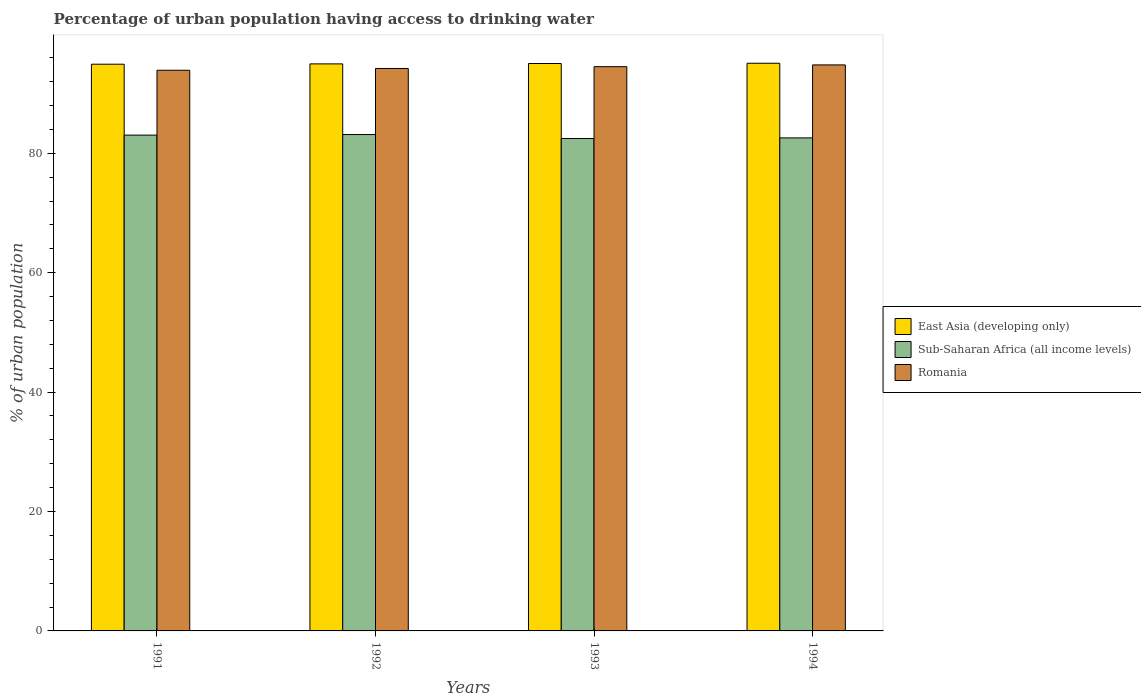How many different coloured bars are there?
Make the answer very short. 3. What is the label of the 1st group of bars from the left?
Provide a succinct answer. 1991. In how many cases, is the number of bars for a given year not equal to the number of legend labels?
Your answer should be compact. 0. What is the percentage of urban population having access to drinking water in Sub-Saharan Africa (all income levels) in 1991?
Your response must be concise. 83.04. Across all years, what is the maximum percentage of urban population having access to drinking water in Romania?
Offer a terse response. 94.8. Across all years, what is the minimum percentage of urban population having access to drinking water in Sub-Saharan Africa (all income levels)?
Offer a very short reply. 82.47. In which year was the percentage of urban population having access to drinking water in East Asia (developing only) maximum?
Ensure brevity in your answer.  1994. In which year was the percentage of urban population having access to drinking water in East Asia (developing only) minimum?
Your response must be concise. 1991. What is the total percentage of urban population having access to drinking water in Romania in the graph?
Your answer should be compact. 377.4. What is the difference between the percentage of urban population having access to drinking water in East Asia (developing only) in 1993 and that in 1994?
Give a very brief answer. -0.04. What is the difference between the percentage of urban population having access to drinking water in Romania in 1992 and the percentage of urban population having access to drinking water in Sub-Saharan Africa (all income levels) in 1994?
Ensure brevity in your answer.  11.63. What is the average percentage of urban population having access to drinking water in East Asia (developing only) per year?
Ensure brevity in your answer.  95. In the year 1991, what is the difference between the percentage of urban population having access to drinking water in Sub-Saharan Africa (all income levels) and percentage of urban population having access to drinking water in Romania?
Your answer should be compact. -10.86. What is the ratio of the percentage of urban population having access to drinking water in Sub-Saharan Africa (all income levels) in 1992 to that in 1993?
Your answer should be very brief. 1.01. What is the difference between the highest and the second highest percentage of urban population having access to drinking water in Sub-Saharan Africa (all income levels)?
Your response must be concise. 0.1. What is the difference between the highest and the lowest percentage of urban population having access to drinking water in Sub-Saharan Africa (all income levels)?
Your response must be concise. 0.66. What does the 2nd bar from the left in 1994 represents?
Make the answer very short. Sub-Saharan Africa (all income levels). What does the 3rd bar from the right in 1992 represents?
Your answer should be compact. East Asia (developing only). Is it the case that in every year, the sum of the percentage of urban population having access to drinking water in Romania and percentage of urban population having access to drinking water in Sub-Saharan Africa (all income levels) is greater than the percentage of urban population having access to drinking water in East Asia (developing only)?
Offer a very short reply. Yes. How many bars are there?
Your response must be concise. 12. Are all the bars in the graph horizontal?
Provide a short and direct response. No. What is the difference between two consecutive major ticks on the Y-axis?
Offer a terse response. 20. Does the graph contain grids?
Keep it short and to the point. No. Where does the legend appear in the graph?
Provide a short and direct response. Center right. How many legend labels are there?
Your answer should be very brief. 3. What is the title of the graph?
Make the answer very short. Percentage of urban population having access to drinking water. Does "Bulgaria" appear as one of the legend labels in the graph?
Offer a very short reply. No. What is the label or title of the X-axis?
Give a very brief answer. Years. What is the label or title of the Y-axis?
Provide a short and direct response. % of urban population. What is the % of urban population in East Asia (developing only) in 1991?
Offer a very short reply. 94.91. What is the % of urban population in Sub-Saharan Africa (all income levels) in 1991?
Offer a very short reply. 83.04. What is the % of urban population of Romania in 1991?
Your answer should be very brief. 93.9. What is the % of urban population of East Asia (developing only) in 1992?
Provide a short and direct response. 94.97. What is the % of urban population of Sub-Saharan Africa (all income levels) in 1992?
Ensure brevity in your answer.  83.13. What is the % of urban population in Romania in 1992?
Make the answer very short. 94.2. What is the % of urban population in East Asia (developing only) in 1993?
Your response must be concise. 95.03. What is the % of urban population of Sub-Saharan Africa (all income levels) in 1993?
Offer a very short reply. 82.47. What is the % of urban population in Romania in 1993?
Your answer should be very brief. 94.5. What is the % of urban population of East Asia (developing only) in 1994?
Offer a terse response. 95.07. What is the % of urban population of Sub-Saharan Africa (all income levels) in 1994?
Provide a short and direct response. 82.57. What is the % of urban population in Romania in 1994?
Offer a very short reply. 94.8. Across all years, what is the maximum % of urban population in East Asia (developing only)?
Offer a terse response. 95.07. Across all years, what is the maximum % of urban population of Sub-Saharan Africa (all income levels)?
Offer a very short reply. 83.13. Across all years, what is the maximum % of urban population of Romania?
Offer a very short reply. 94.8. Across all years, what is the minimum % of urban population of East Asia (developing only)?
Offer a terse response. 94.91. Across all years, what is the minimum % of urban population in Sub-Saharan Africa (all income levels)?
Make the answer very short. 82.47. Across all years, what is the minimum % of urban population in Romania?
Provide a succinct answer. 93.9. What is the total % of urban population of East Asia (developing only) in the graph?
Offer a terse response. 379.99. What is the total % of urban population in Sub-Saharan Africa (all income levels) in the graph?
Make the answer very short. 331.22. What is the total % of urban population in Romania in the graph?
Ensure brevity in your answer.  377.4. What is the difference between the % of urban population of East Asia (developing only) in 1991 and that in 1992?
Offer a terse response. -0.05. What is the difference between the % of urban population of Sub-Saharan Africa (all income levels) in 1991 and that in 1992?
Ensure brevity in your answer.  -0.1. What is the difference between the % of urban population of Romania in 1991 and that in 1992?
Keep it short and to the point. -0.3. What is the difference between the % of urban population in East Asia (developing only) in 1991 and that in 1993?
Your response must be concise. -0.12. What is the difference between the % of urban population in Sub-Saharan Africa (all income levels) in 1991 and that in 1993?
Offer a terse response. 0.57. What is the difference between the % of urban population of Romania in 1991 and that in 1993?
Your answer should be compact. -0.6. What is the difference between the % of urban population of East Asia (developing only) in 1991 and that in 1994?
Offer a terse response. -0.16. What is the difference between the % of urban population of Sub-Saharan Africa (all income levels) in 1991 and that in 1994?
Your answer should be very brief. 0.47. What is the difference between the % of urban population in Romania in 1991 and that in 1994?
Ensure brevity in your answer.  -0.9. What is the difference between the % of urban population in East Asia (developing only) in 1992 and that in 1993?
Give a very brief answer. -0.06. What is the difference between the % of urban population in Sub-Saharan Africa (all income levels) in 1992 and that in 1993?
Your answer should be compact. 0.66. What is the difference between the % of urban population in Romania in 1992 and that in 1993?
Ensure brevity in your answer.  -0.3. What is the difference between the % of urban population in East Asia (developing only) in 1992 and that in 1994?
Offer a terse response. -0.11. What is the difference between the % of urban population in Sub-Saharan Africa (all income levels) in 1992 and that in 1994?
Keep it short and to the point. 0.56. What is the difference between the % of urban population in East Asia (developing only) in 1993 and that in 1994?
Offer a terse response. -0.04. What is the difference between the % of urban population of Sub-Saharan Africa (all income levels) in 1993 and that in 1994?
Offer a very short reply. -0.1. What is the difference between the % of urban population of Romania in 1993 and that in 1994?
Provide a short and direct response. -0.3. What is the difference between the % of urban population in East Asia (developing only) in 1991 and the % of urban population in Sub-Saharan Africa (all income levels) in 1992?
Offer a very short reply. 11.78. What is the difference between the % of urban population of East Asia (developing only) in 1991 and the % of urban population of Romania in 1992?
Keep it short and to the point. 0.71. What is the difference between the % of urban population of Sub-Saharan Africa (all income levels) in 1991 and the % of urban population of Romania in 1992?
Your answer should be compact. -11.16. What is the difference between the % of urban population of East Asia (developing only) in 1991 and the % of urban population of Sub-Saharan Africa (all income levels) in 1993?
Ensure brevity in your answer.  12.44. What is the difference between the % of urban population of East Asia (developing only) in 1991 and the % of urban population of Romania in 1993?
Give a very brief answer. 0.41. What is the difference between the % of urban population in Sub-Saharan Africa (all income levels) in 1991 and the % of urban population in Romania in 1993?
Provide a short and direct response. -11.46. What is the difference between the % of urban population of East Asia (developing only) in 1991 and the % of urban population of Sub-Saharan Africa (all income levels) in 1994?
Ensure brevity in your answer.  12.34. What is the difference between the % of urban population of East Asia (developing only) in 1991 and the % of urban population of Romania in 1994?
Ensure brevity in your answer.  0.11. What is the difference between the % of urban population in Sub-Saharan Africa (all income levels) in 1991 and the % of urban population in Romania in 1994?
Make the answer very short. -11.76. What is the difference between the % of urban population in East Asia (developing only) in 1992 and the % of urban population in Sub-Saharan Africa (all income levels) in 1993?
Make the answer very short. 12.49. What is the difference between the % of urban population of East Asia (developing only) in 1992 and the % of urban population of Romania in 1993?
Your answer should be compact. 0.47. What is the difference between the % of urban population in Sub-Saharan Africa (all income levels) in 1992 and the % of urban population in Romania in 1993?
Offer a terse response. -11.37. What is the difference between the % of urban population of East Asia (developing only) in 1992 and the % of urban population of Sub-Saharan Africa (all income levels) in 1994?
Offer a terse response. 12.4. What is the difference between the % of urban population of East Asia (developing only) in 1992 and the % of urban population of Romania in 1994?
Give a very brief answer. 0.17. What is the difference between the % of urban population in Sub-Saharan Africa (all income levels) in 1992 and the % of urban population in Romania in 1994?
Offer a terse response. -11.67. What is the difference between the % of urban population of East Asia (developing only) in 1993 and the % of urban population of Sub-Saharan Africa (all income levels) in 1994?
Ensure brevity in your answer.  12.46. What is the difference between the % of urban population in East Asia (developing only) in 1993 and the % of urban population in Romania in 1994?
Provide a succinct answer. 0.23. What is the difference between the % of urban population of Sub-Saharan Africa (all income levels) in 1993 and the % of urban population of Romania in 1994?
Offer a terse response. -12.33. What is the average % of urban population of East Asia (developing only) per year?
Offer a very short reply. 95. What is the average % of urban population in Sub-Saharan Africa (all income levels) per year?
Provide a short and direct response. 82.8. What is the average % of urban population in Romania per year?
Provide a short and direct response. 94.35. In the year 1991, what is the difference between the % of urban population of East Asia (developing only) and % of urban population of Sub-Saharan Africa (all income levels)?
Your answer should be very brief. 11.88. In the year 1991, what is the difference between the % of urban population of East Asia (developing only) and % of urban population of Romania?
Your response must be concise. 1.01. In the year 1991, what is the difference between the % of urban population in Sub-Saharan Africa (all income levels) and % of urban population in Romania?
Offer a very short reply. -10.86. In the year 1992, what is the difference between the % of urban population in East Asia (developing only) and % of urban population in Sub-Saharan Africa (all income levels)?
Your response must be concise. 11.83. In the year 1992, what is the difference between the % of urban population of East Asia (developing only) and % of urban population of Romania?
Offer a terse response. 0.77. In the year 1992, what is the difference between the % of urban population in Sub-Saharan Africa (all income levels) and % of urban population in Romania?
Your answer should be very brief. -11.07. In the year 1993, what is the difference between the % of urban population in East Asia (developing only) and % of urban population in Sub-Saharan Africa (all income levels)?
Offer a terse response. 12.56. In the year 1993, what is the difference between the % of urban population in East Asia (developing only) and % of urban population in Romania?
Make the answer very short. 0.53. In the year 1993, what is the difference between the % of urban population in Sub-Saharan Africa (all income levels) and % of urban population in Romania?
Ensure brevity in your answer.  -12.03. In the year 1994, what is the difference between the % of urban population of East Asia (developing only) and % of urban population of Sub-Saharan Africa (all income levels)?
Make the answer very short. 12.5. In the year 1994, what is the difference between the % of urban population of East Asia (developing only) and % of urban population of Romania?
Your answer should be very brief. 0.27. In the year 1994, what is the difference between the % of urban population in Sub-Saharan Africa (all income levels) and % of urban population in Romania?
Make the answer very short. -12.23. What is the ratio of the % of urban population in East Asia (developing only) in 1991 to that in 1992?
Make the answer very short. 1. What is the ratio of the % of urban population in Sub-Saharan Africa (all income levels) in 1991 to that in 1992?
Your response must be concise. 1. What is the ratio of the % of urban population of Romania in 1991 to that in 1992?
Make the answer very short. 1. What is the ratio of the % of urban population of Sub-Saharan Africa (all income levels) in 1991 to that in 1993?
Keep it short and to the point. 1.01. What is the ratio of the % of urban population of Romania in 1991 to that in 1993?
Ensure brevity in your answer.  0.99. What is the ratio of the % of urban population of Sub-Saharan Africa (all income levels) in 1992 to that in 1994?
Your answer should be compact. 1.01. What is the ratio of the % of urban population in Romania in 1993 to that in 1994?
Provide a succinct answer. 1. What is the difference between the highest and the second highest % of urban population in East Asia (developing only)?
Keep it short and to the point. 0.04. What is the difference between the highest and the second highest % of urban population in Sub-Saharan Africa (all income levels)?
Offer a terse response. 0.1. What is the difference between the highest and the second highest % of urban population of Romania?
Offer a terse response. 0.3. What is the difference between the highest and the lowest % of urban population of East Asia (developing only)?
Keep it short and to the point. 0.16. What is the difference between the highest and the lowest % of urban population of Sub-Saharan Africa (all income levels)?
Your answer should be very brief. 0.66. What is the difference between the highest and the lowest % of urban population of Romania?
Give a very brief answer. 0.9. 